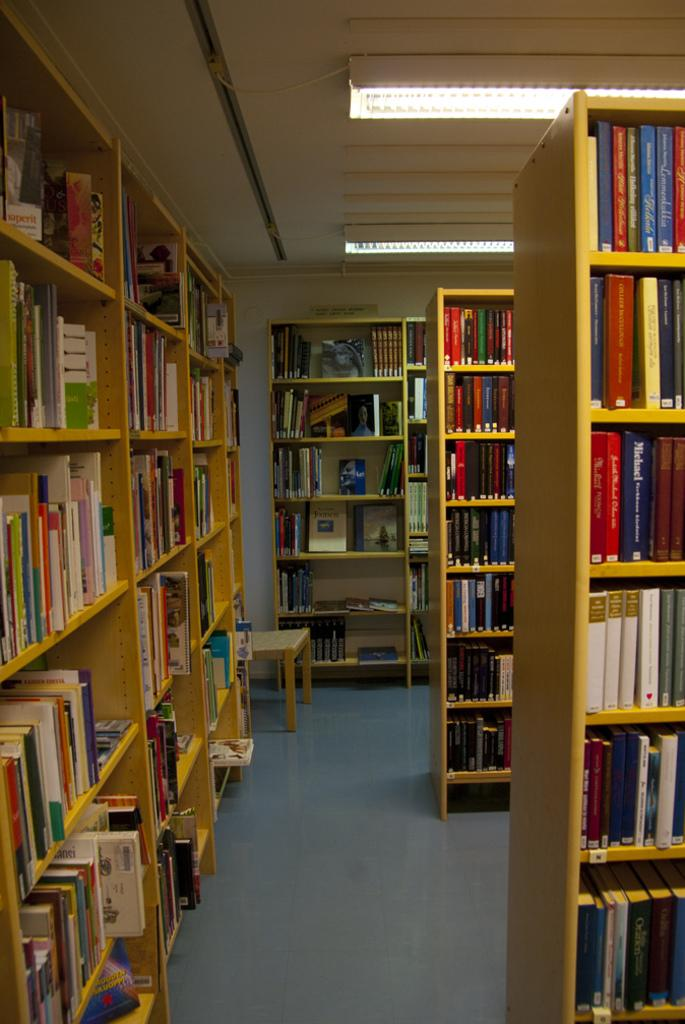What type of place is depicted in the image? The image is an inside view of a library. What can be seen in the wooden rack in the front of the image? There are books in the wooden rack in the front of the image. What type of truck is parked outside the library in the image? There is no truck visible in the image, as it is an inside view of the library. 